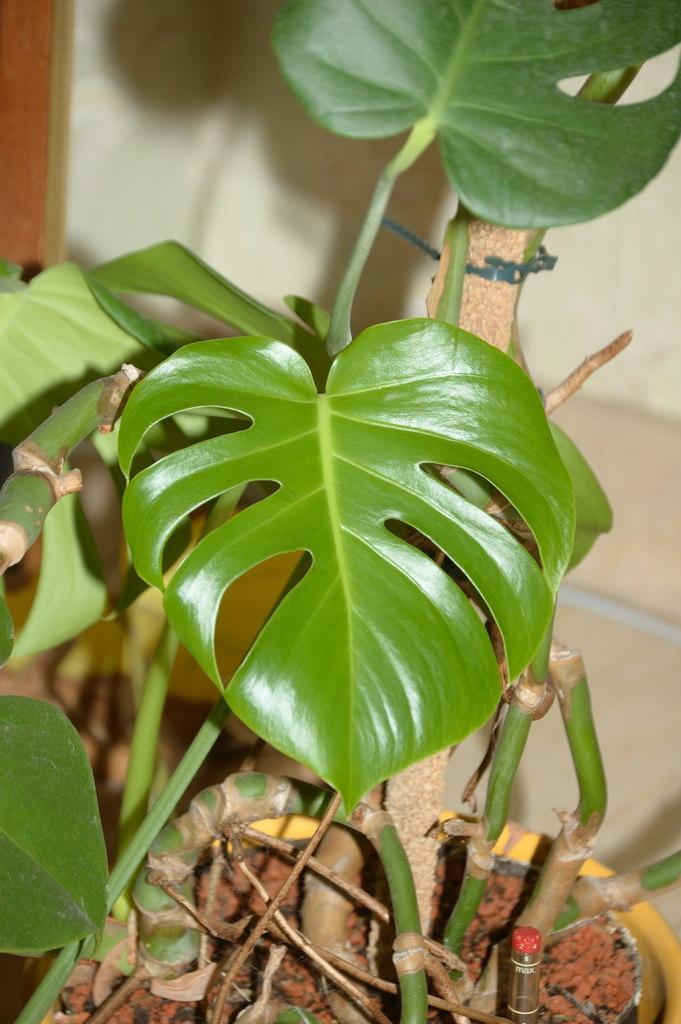What is located in the front of the image? There is a plant in the front of the image. What can be seen in the background of the image? There is a wall in the background of the image. Is there a scarecrow standing next to the plant in the image? No, there is no scarecrow present in the image. Can you hear someone coughing in the background of the image? There is no sound present in the image, so it is impossible to determine if someone is coughing. 